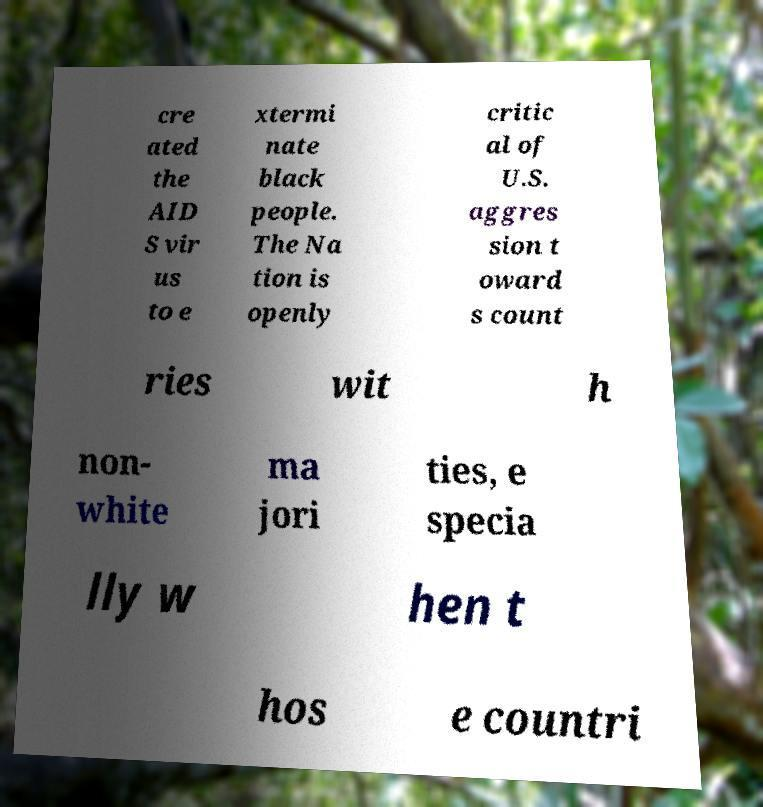Please identify and transcribe the text found in this image. cre ated the AID S vir us to e xtermi nate black people. The Na tion is openly critic al of U.S. aggres sion t oward s count ries wit h non- white ma jori ties, e specia lly w hen t hos e countri 